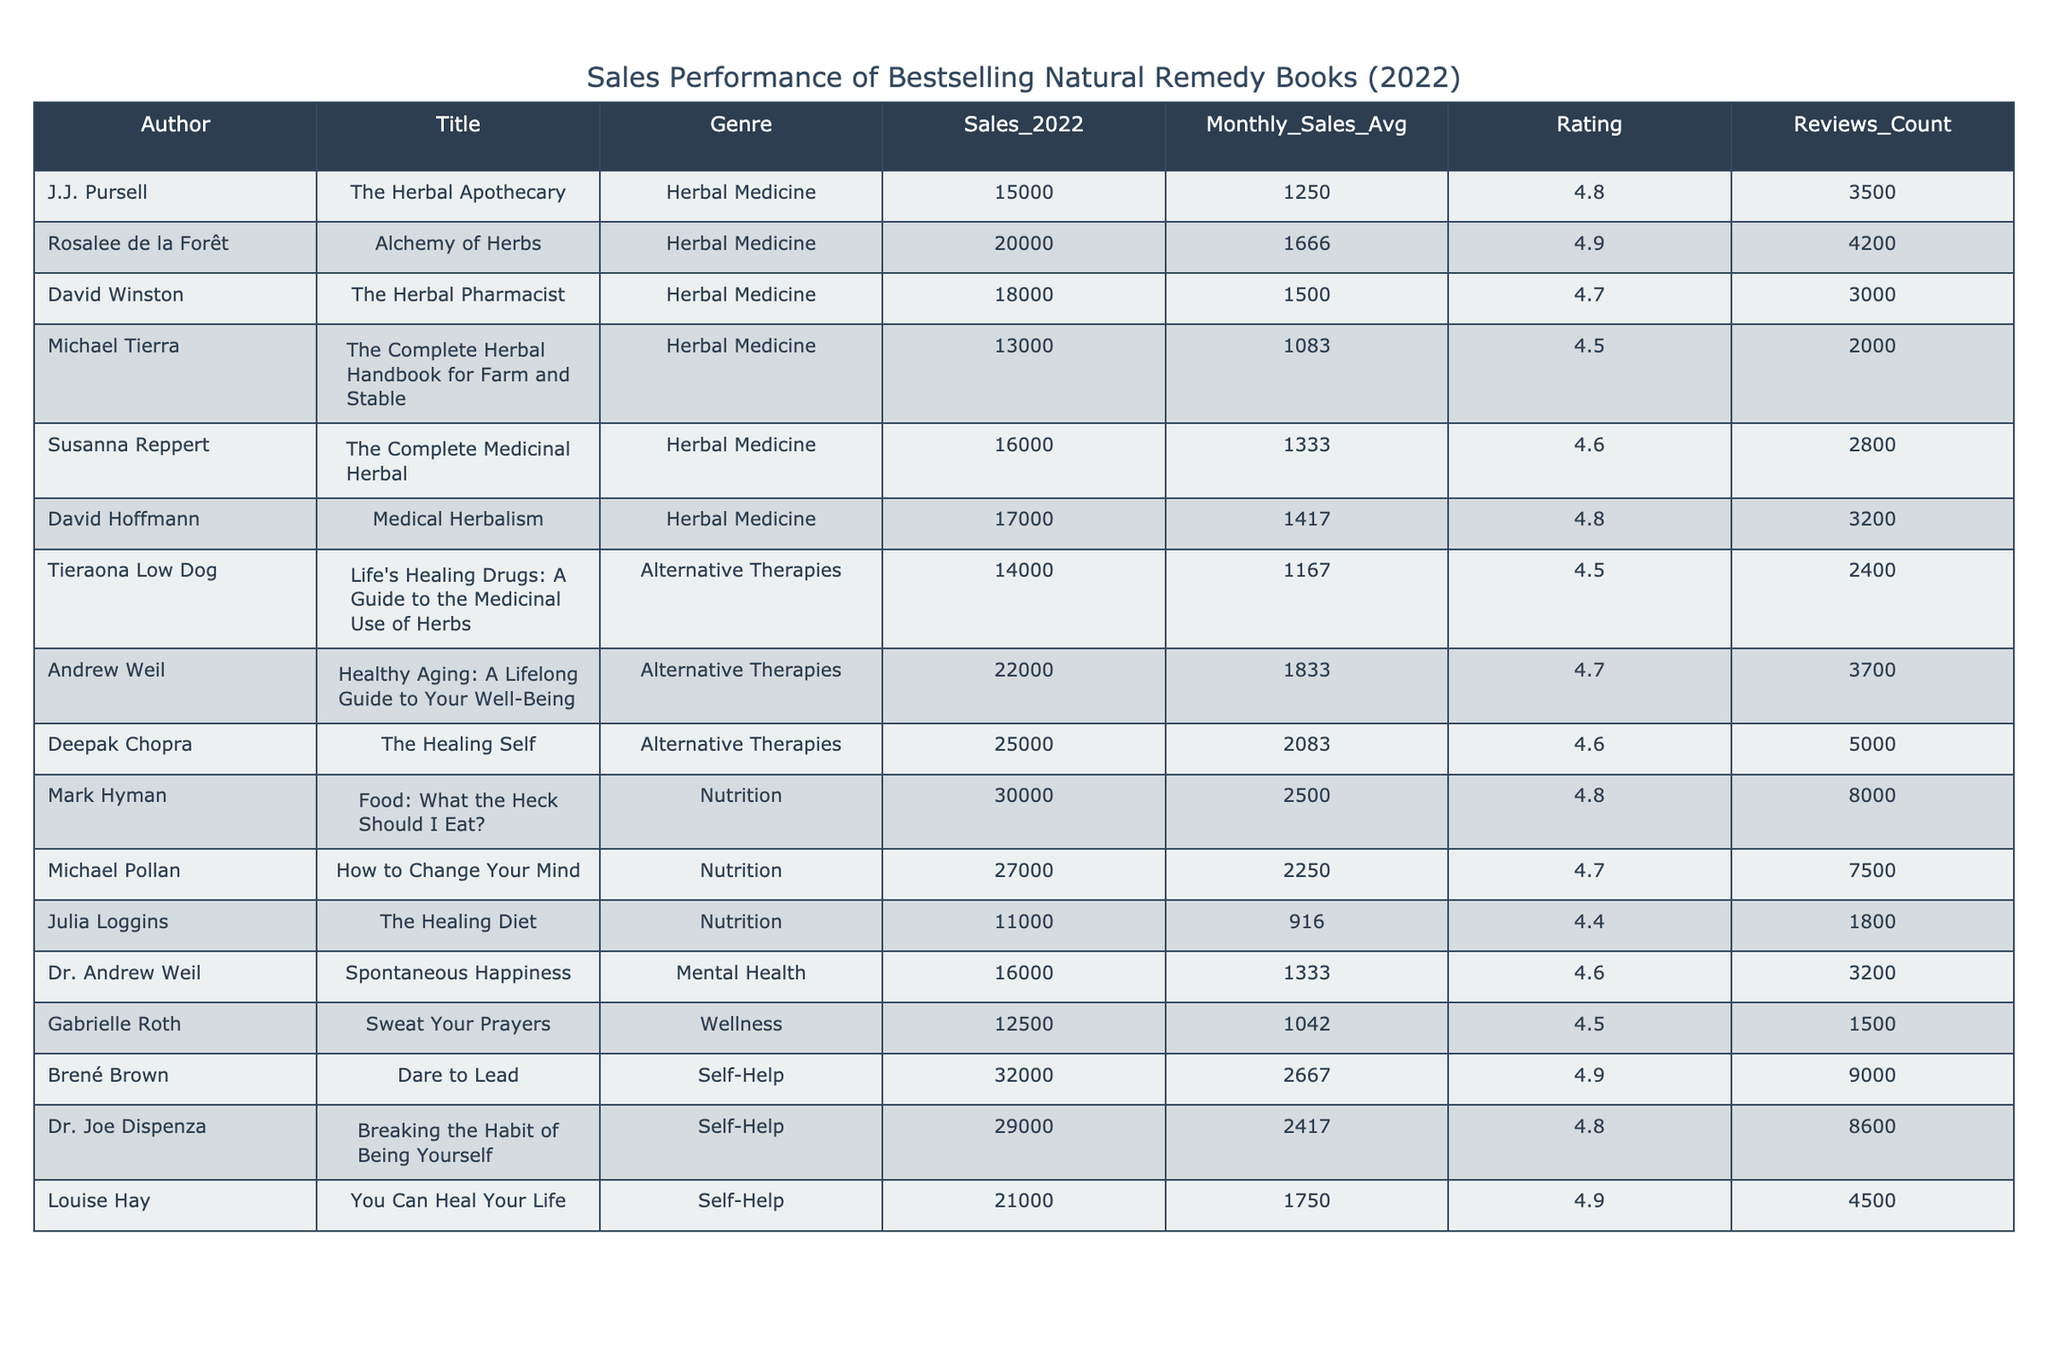What is the genre of "Dare to Lead"? The table shows a column for Genre, and we can locate "Dare to Lead" in the Title column. Its corresponding Genre as indicated in the same row is "Self-Help".
Answer: Self-Help Who had the highest monthly sales average in 2022? We look at the Monthly Sales Avg column and identify the highest value, which is 2500 associated with the title "Food: What the Heck Should I Eat?" by Mark Hyman.
Answer: 2500 What is the total sales of Herbal Medicine books? We sum the Sales_2022 column for all titles under the Herbal Medicine genre: 15000 + 20000 + 18000 + 13000 + 16000 + 17000 = 109000.
Answer: 109000 Which author received the most reviews? By examining the Reviews_Count column, we see "Dare to Lead" by Brené Brown has the highest reviews count, which is 9000, more than any other author.
Answer: 9000 Is "The Healing Self" rated higher than "Life's Healing Drugs"? Comparing the Rating column, "The Healing Self" has a rating of 4.6 while "Life's Healing Drugs" has 4.5, indicating "The Healing Self" is rated higher.
Answer: Yes What is the average rating of all books listed? To find the average rating, we sum the ratings: 4.8 + 4.9 + 4.7 + 4.5 + 4.6 + 4.8 + 4.5 + 4.7 + 4.6 + 4.8 + 4.4 + 4.6 + 4.5 + 4.9 + 4.8 = 69.7. There are 15 books, so the average is 69.7 / 15 = 4.6467 (approximately 4.65).
Answer: 4.65 Which genre had the least total sales in 2022? We compute the total sales for each genre: Herbal Medicine = 109000, Alternative Therapies = 42000, Nutrition = 68000, Mental Health = 16000, Wellness = 12500, Self-Help = 81000. The least total sales are from Mental Health.
Answer: Mental Health If "Breaking the Habit of Being Yourself" is removed from the list, what would be the new total sales for Self-Help? Removing the sales of "Breaking the Habit of Being Yourself" which is 29000 from the total sales of Self-Help which was previously 81000 gives us 81000 - 29000 = 52000.
Answer: 52000 Which author has both a high sales figure and a high rating? We compare significant sales and ratings; "Deepak Chopra" with "The Healing Self" has a high sales of 25000 and a rating of 4.6, making him a match for both high sales and rating.
Answer: Deepak Chopra Is there any book with a monthly sales average less than 1000? We can see from the Monthly_Sales_Avg column that all entries are above 1000. Thus, there are no books listed with monthly sales average less than 1000.
Answer: No 